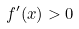Convert formula to latex. <formula><loc_0><loc_0><loc_500><loc_500>f ^ { \prime } ( x ) > 0</formula> 